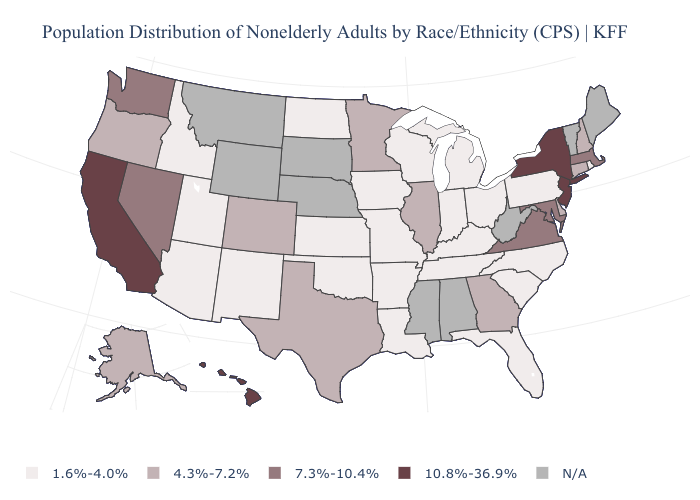What is the value of South Carolina?
Concise answer only. 1.6%-4.0%. Name the states that have a value in the range 10.8%-36.9%?
Keep it brief. California, Hawaii, New Jersey, New York. What is the lowest value in the West?
Short answer required. 1.6%-4.0%. What is the value of Oklahoma?
Be succinct. 1.6%-4.0%. What is the value of Hawaii?
Be succinct. 10.8%-36.9%. Among the states that border Oklahoma , does Texas have the lowest value?
Give a very brief answer. No. What is the value of Kentucky?
Answer briefly. 1.6%-4.0%. Is the legend a continuous bar?
Quick response, please. No. Is the legend a continuous bar?
Keep it brief. No. What is the value of Nevada?
Answer briefly. 7.3%-10.4%. Among the states that border Kentucky , which have the highest value?
Answer briefly. Virginia. Does Idaho have the lowest value in the West?
Short answer required. Yes. 